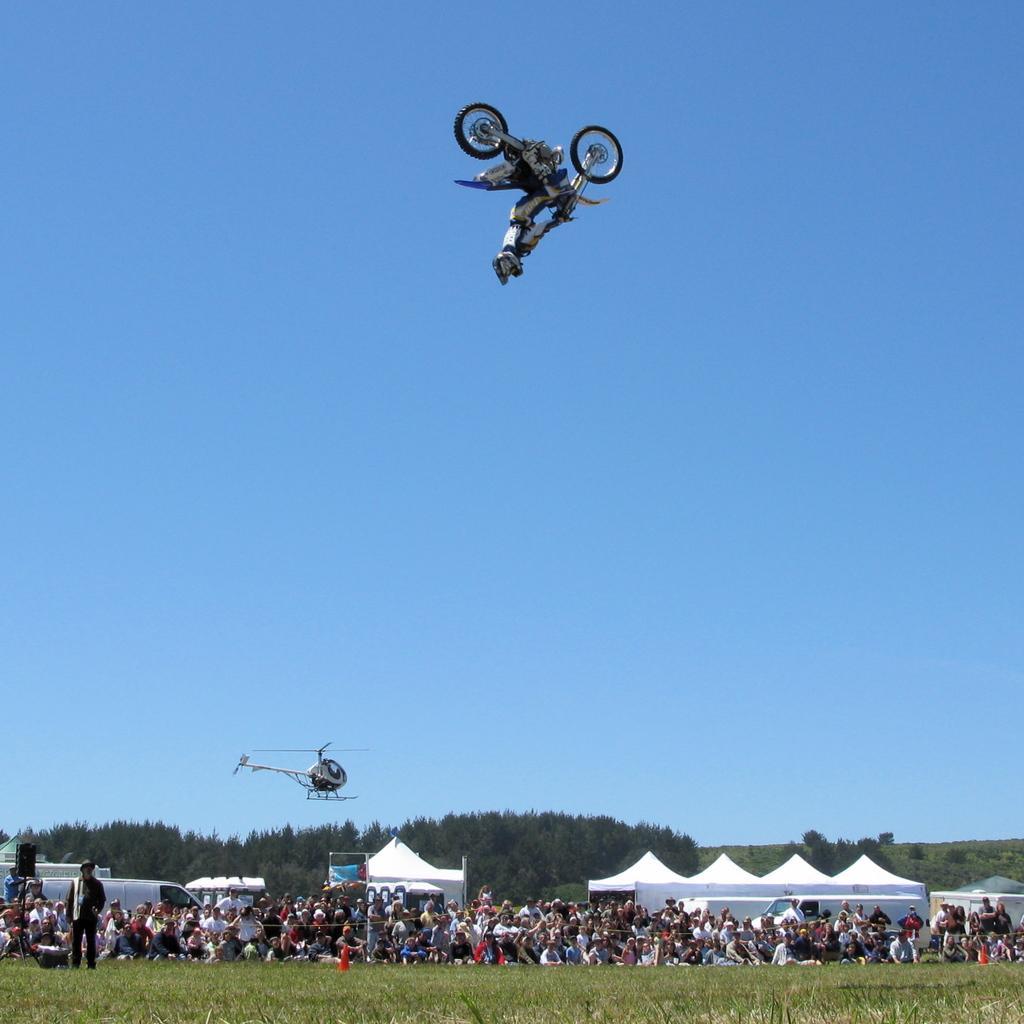How would you summarize this image in a sentence or two? Here we can see a man doing stunts with a bike in the air and there is a helicopter flying in the sky. In the background we can see few people are sitting on the chairs and few are standing and there are tents,trees and clouds in the sky. 